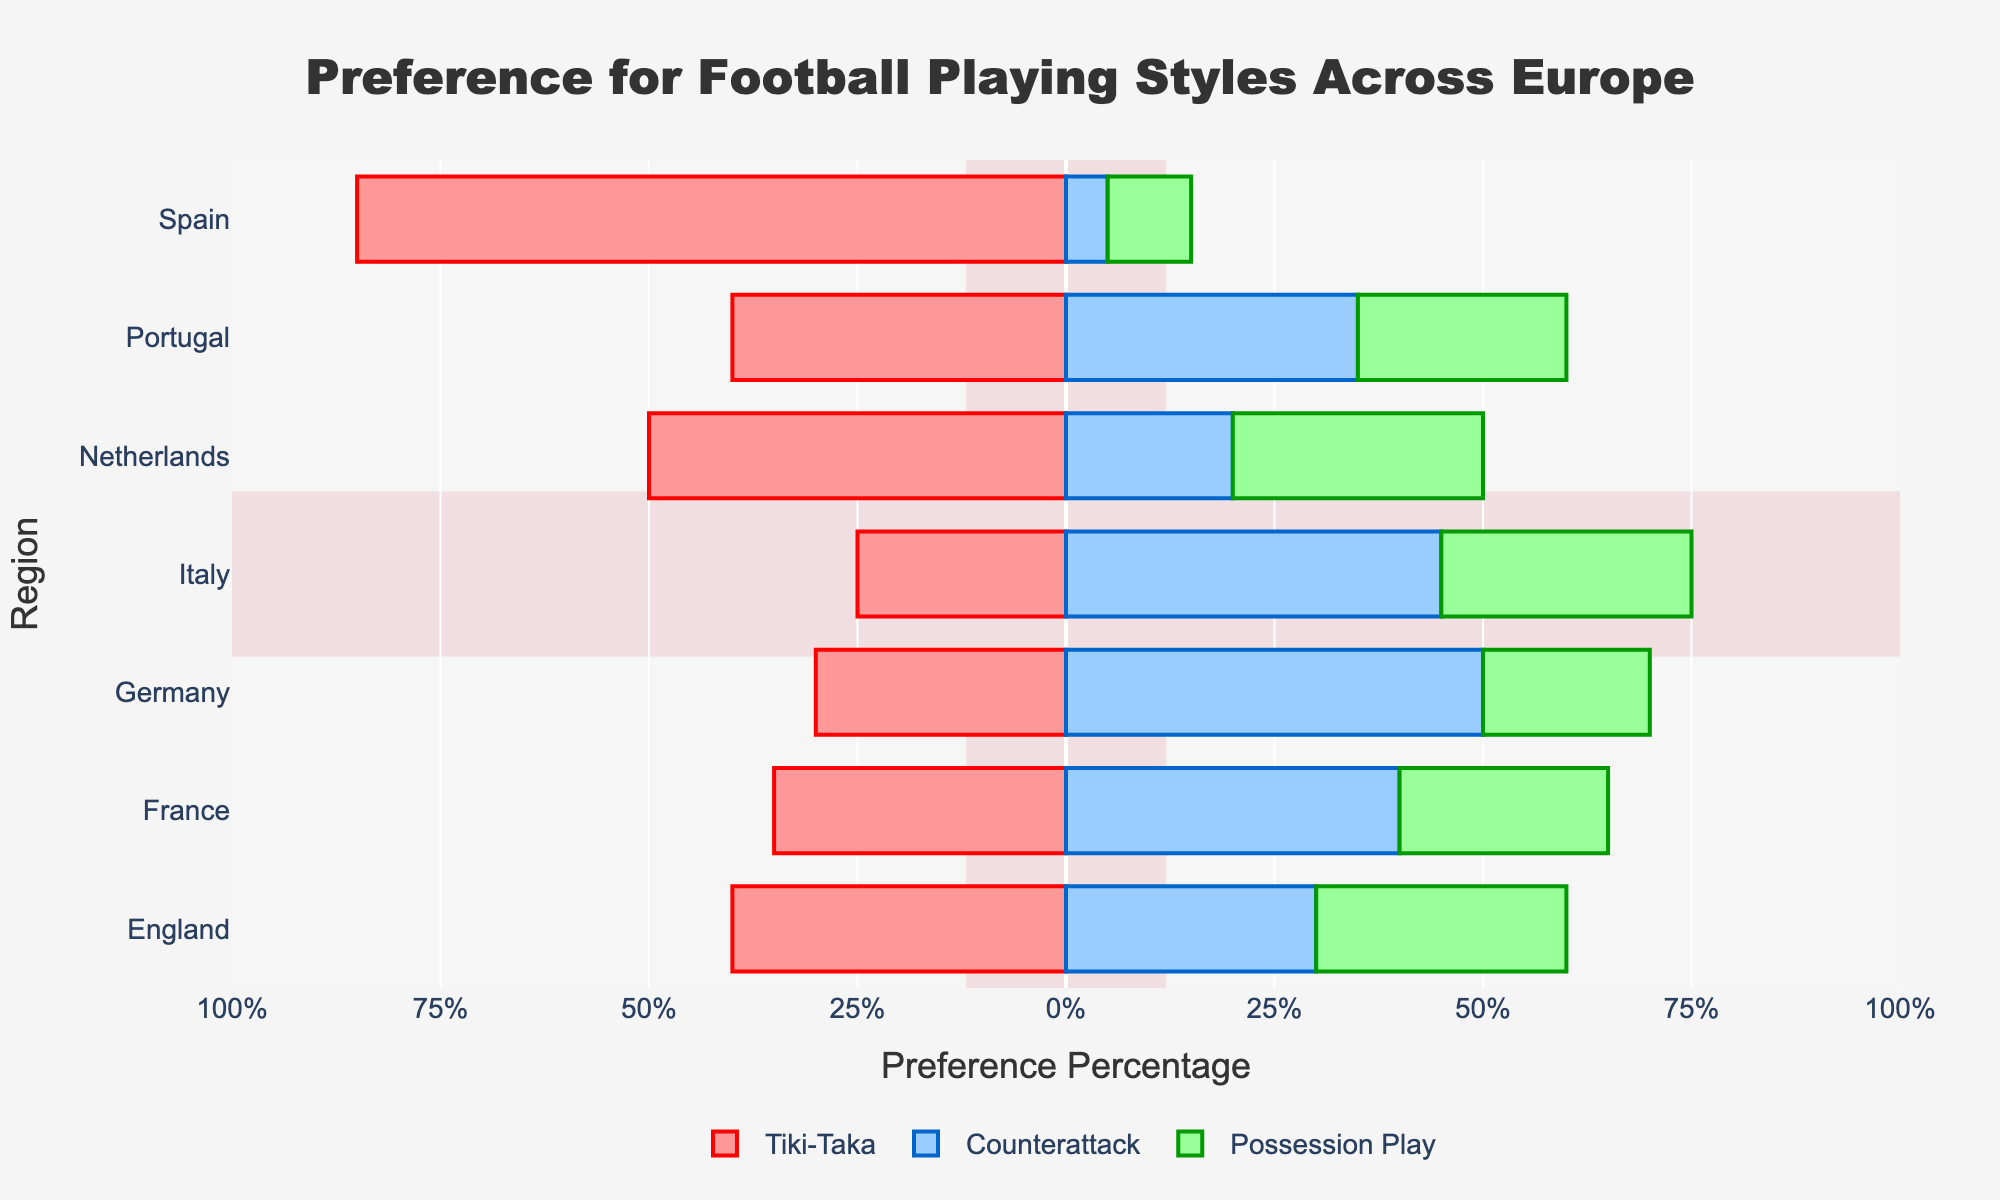Which region has the highest preference for Tiki-Taka? By looking at the diverging stacked bar chart, we examine the horizontal bars labeled for Tiki-Taka. The longest Tiki-Taka bar extends to 85% for Spain, which is the highest among all regions.
Answer: Spain What is the total percentage preference for Counterattack and Possession Play in Italy? To get this total, we sum the preference percentages for Counterattack (45%) and Possession Play (30%) in Italy. 45% + 30% equals 75%.
Answer: 75% Which region has an equal preference for all three playing styles? Analyzing the bars for each region, we see that England shows a 30% preference for both Counterattack and Possession Play, but for Tiki-Taka, the preference is 40%, which isn’t equal. None of the regions show equal preference for all three styles.
Answer: None Is the preference for Counterattack greater in Germany or France? We compare the lengths of the blue bars representing Counterattack for Germany and France. Germany’s preference for Counterattack is at 50%, whereas France’s is at 40%. Thus, Germany has a greater preference.
Answer: Germany Which countries have a higher preference for Possession Play than Tiki-Taka? To answer this, we identify regions where the green bar (Possession Play) is longer than the red bar (Tiki-Taka). The regions with higher Possession Play preferences than Tiki-Taka are Italy (30% > 25%) and France (25% > 35%).
Answer: Italy and France What is the combined preference percentage of Tiki-Taka and Counterattack in Spain and Portugal? First, we calculate the combined percentage for Spain: Tiki-Taka (85%) + Counterattack (5%) = 90%. For Portugal: Tiki-Taka (40%) + Counterattack (35%) = 75%. Summing these values: 90% + 75% = 165%.
Answer: 165% Which playing style does the Netherlands prefer the least? We examine the preference percentages for the Netherlands: Tiki-Taka (50%), Counterattack (20%), and Possession Play (30%). The smallest value is for Counterattack.
Answer: Counterattack How does the preference for Possession Play in England compare to Spain? Comparing the lengths of the green bars, Possession Play for England is 30%, while for Spain it is 10%. Therefore, England has a higher preference for Possession Play.
Answer: England What is the average preference for Tiki-Taka across all regions? To find the average, sum the Tiki-Taka percentages for all regions: 85 (Spain) + 30 (Germany) + 25 (Italy) + 40 (England) + 35 (France) + 50 (Netherlands) + 40 (Portugal) = 305. Then, divide by the number of regions (7): 305 / 7 ≈ 43.57%.
Answer: 43.57% Which region shows the least variation in preferences between the three playing styles? The region with the smallest range between the highest and lowest preference percentages will be the answer. Spain has the highest variation (85% Tiki-Taka, 5% Counterattack), whereas England shows a relatively balanced distribution (40% Tiki-Taka, 30% Counterattack, 30% Possession Play).
Answer: England 